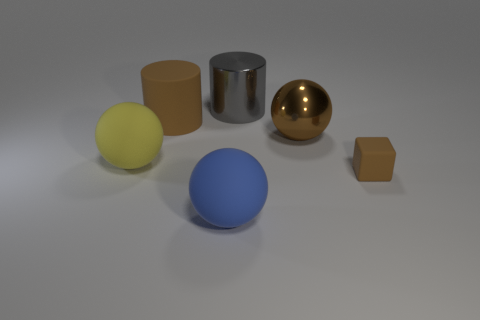Is there anything else that is the same shape as the tiny matte object?
Keep it short and to the point. No. Does the big ball in front of the yellow matte thing have the same color as the rubber sphere behind the tiny brown cube?
Give a very brief answer. No. What number of big brown objects are on the right side of the large blue rubber sphere?
Your response must be concise. 1. What number of metallic cylinders are the same color as the shiny sphere?
Make the answer very short. 0. Do the ball behind the yellow rubber object and the large gray thing have the same material?
Provide a short and direct response. Yes. How many tiny brown blocks are the same material as the tiny object?
Your answer should be very brief. 0. Are there more large brown metallic spheres that are behind the big gray cylinder than large brown matte objects?
Give a very brief answer. No. What is the size of the cylinder that is the same color as the tiny matte block?
Provide a succinct answer. Large. Are there any other small things of the same shape as the brown shiny object?
Your answer should be very brief. No. What number of things are either large brown cylinders or large brown shiny things?
Your answer should be very brief. 2. 